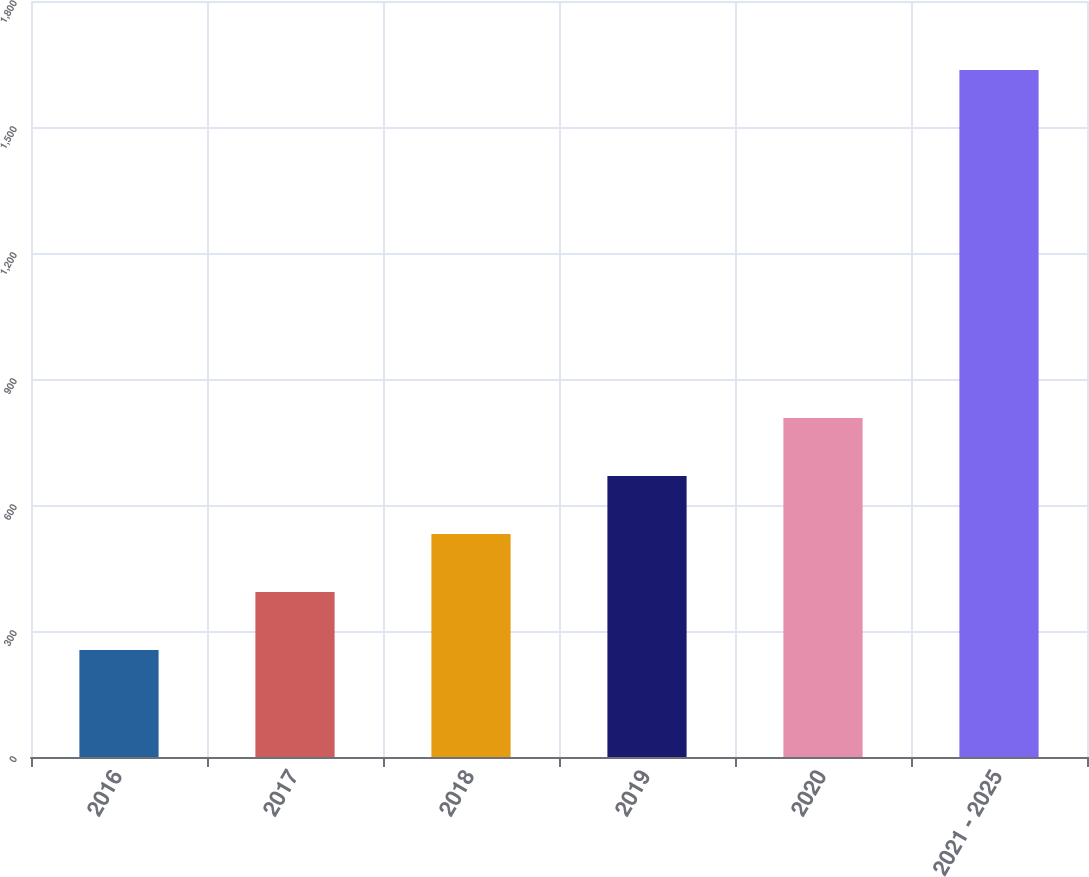Convert chart. <chart><loc_0><loc_0><loc_500><loc_500><bar_chart><fcel>2016<fcel>2017<fcel>2018<fcel>2019<fcel>2020<fcel>2021 - 2025<nl><fcel>255<fcel>393.1<fcel>531.2<fcel>669.3<fcel>807.4<fcel>1636<nl></chart> 